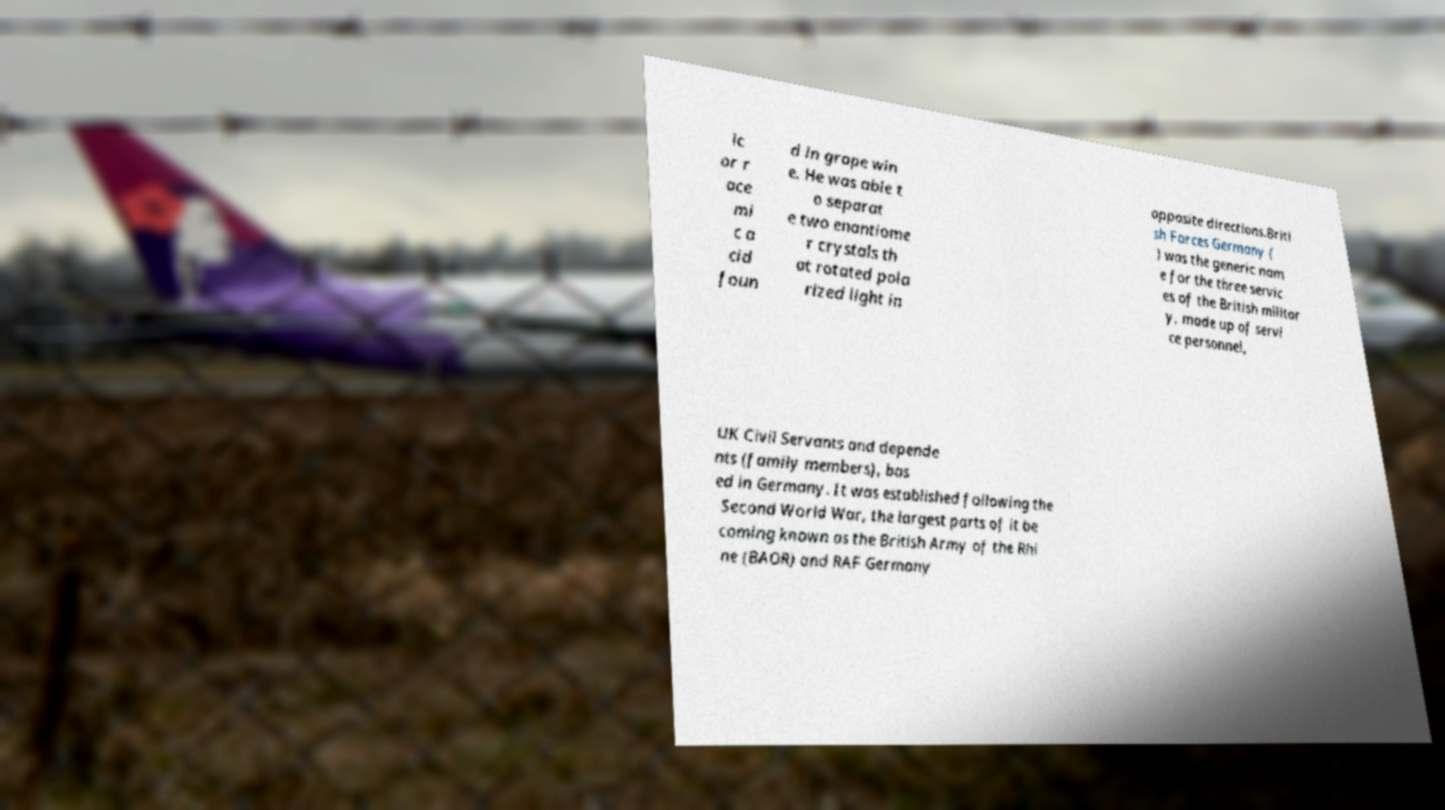Please identify and transcribe the text found in this image. ic or r ace mi c a cid foun d in grape win e. He was able t o separat e two enantiome r crystals th at rotated pola rized light in opposite directions.Briti sh Forces Germany ( ) was the generic nam e for the three servic es of the British militar y, made up of servi ce personnel, UK Civil Servants and depende nts (family members), bas ed in Germany. It was established following the Second World War, the largest parts of it be coming known as the British Army of the Rhi ne (BAOR) and RAF Germany 